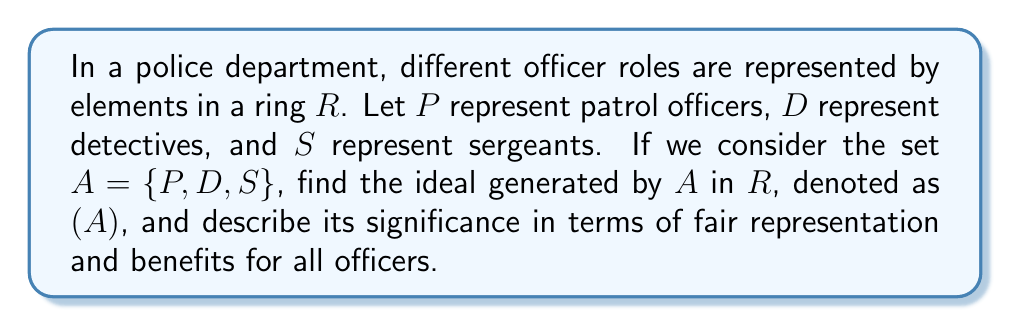Show me your answer to this math problem. To solve this problem, we need to understand the concept of an ideal generated by a set in ring theory and apply it to the given context:

1) The ideal generated by a set $A$ in a ring $R$, denoted as $(A)$, is the smallest ideal of $R$ that contains all elements of $A$.

2) Mathematically, $(A) = \{r_1a_1 + r_2a_2 + ... + r_na_n | r_i \in R, a_i \in A, n \in \mathbb{N}\}$

3) In our case, $A = \{P, D, S\}$, so the ideal $(A)$ will consist of all linear combinations of $P$, $D$, and $S$ with coefficients from $R$.

4) Explicitly, $(A) = \{r_1P + r_2D + r_3S | r_1, r_2, r_3 \in R\}$

5) This means that any element in the ideal can be expressed as a sum of multiples of patrol officers, detectives, and sergeants.

In the context of fair representation and benefits:

6) The ideal $(A)$ represents all possible combinations and proportions of these officer roles that can be considered in policy decisions.

7) Any element in $(A)$ ensures that all three roles (patrol, detective, sergeant) are taken into account, promoting equitable treatment.

8) The coefficients $r_1$, $r_2$, and $r_3$ can represent factors like seniority, risk level, or workload for each role, allowing for nuanced policy decisions.

9) By considering elements from $(A)$, the union ensures that no officer role is overlooked in negotiations or benefit distributions.
Answer: The ideal generated by $A = \{P, D, S\}$ in $R$ is:

$$(A) = \{r_1P + r_2D + r_3S | r_1, r_2, r_3 \in R\}$$

This ideal represents all possible combinations of officer roles that ensure fair representation and consideration in policy decisions and benefit allocations. 